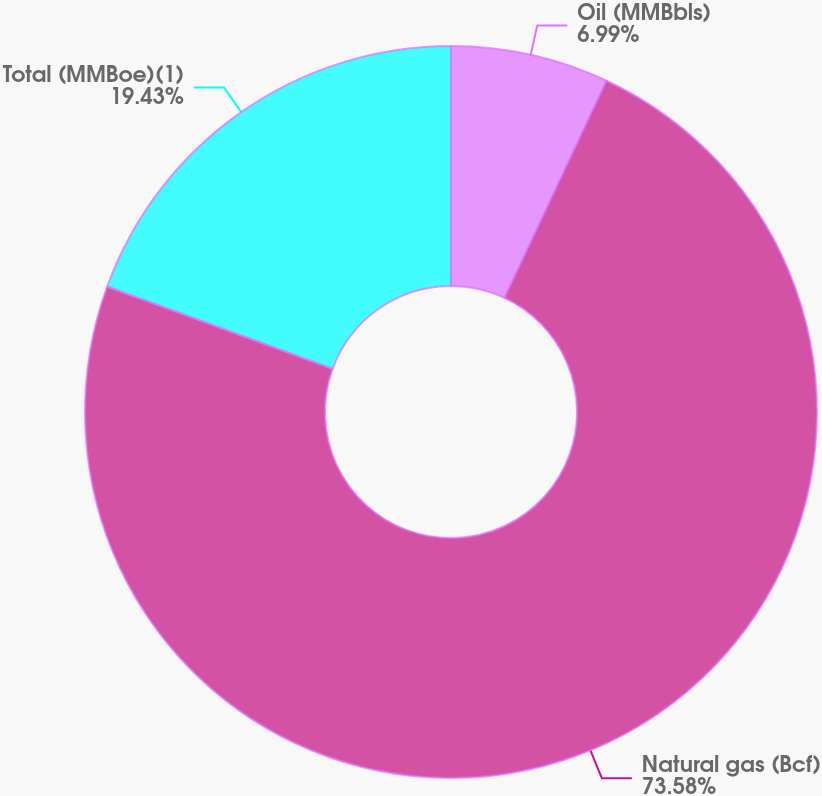Convert chart. <chart><loc_0><loc_0><loc_500><loc_500><pie_chart><fcel>Oil (MMBbls)<fcel>Natural gas (Bcf)<fcel>Total (MMBoe)(1)<nl><fcel>6.99%<fcel>73.58%<fcel>19.43%<nl></chart> 